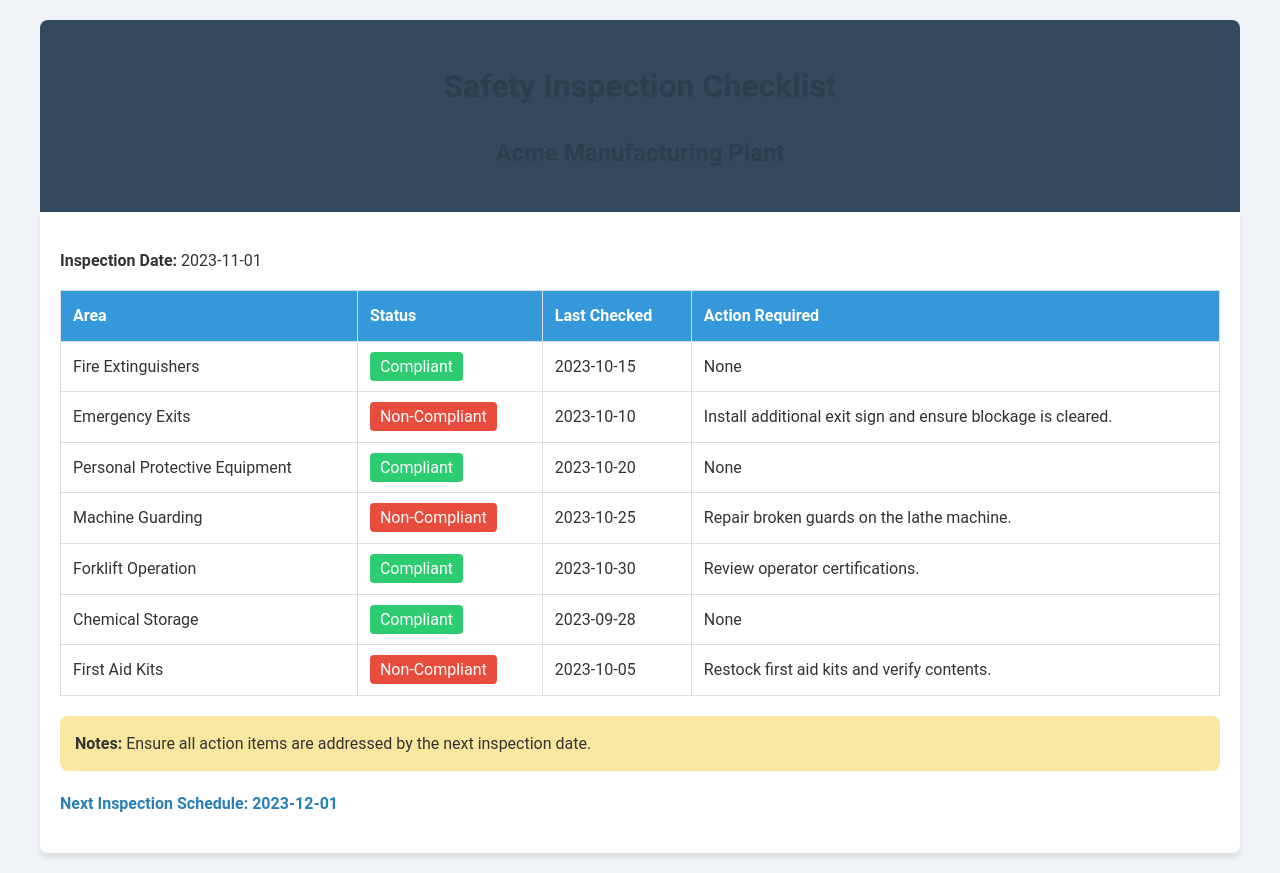What is the inspection date? The inspection date is explicitly mentioned in the document as the date when the safety checklist was completed.
Answer: 2023-11-01 Which area requires the installation of additional exit signs? The document indicates which areas are compliant or non-compliant and details the action required for non-compliant areas.
Answer: Emergency Exits What is the status of Personal Protective Equipment? The status of each area is noted in the document, indicating whether they are compliant or non-compliant.
Answer: Compliant What action is required for the Machine Guarding area? The action required for areas indicates what needs to be done to rectify non-compliance.
Answer: Repair broken guards on the lathe machine When was the last check for the First Aid Kits? The document states the last checked date for each area, indicating when inspections were last conducted.
Answer: 2023-10-05 How many areas are listed as non-compliant? A count of the areas under the non-compliant status provides insight into how many issues need to be addressed.
Answer: Three What should be reviewed regarding Forklift Operation? The document specifies actions required that relate directly to the compliance of specific areas, providing detail on necessary checks.
Answer: Review operator certifications What is the next inspection date? The next inspection date is noted at the end of the document, helping to understand the frequency of inspections.
Answer: 2023-12-01 